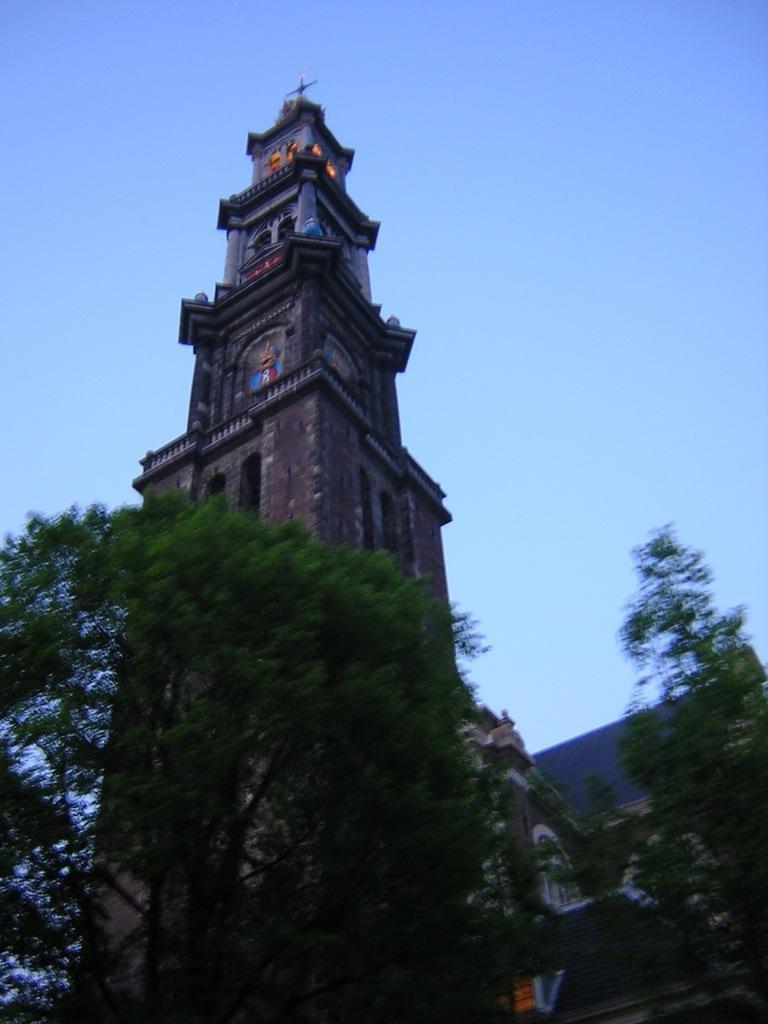Please provide a concise description of this image. In this image we can see a building with windows. We can also see some trees and the sky which looks cloudy. 